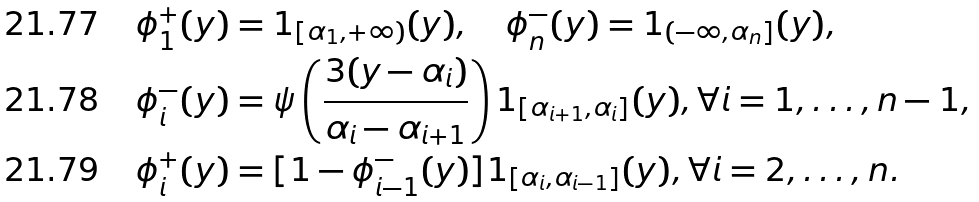<formula> <loc_0><loc_0><loc_500><loc_500>& \phi _ { 1 } ^ { + } ( y ) = 1 _ { [ \alpha _ { 1 } , + \infty ) } ( y ) , \quad \phi _ { n } ^ { - } ( y ) = 1 _ { ( - \infty , \alpha _ { n } ] } ( y ) , \\ & \phi _ { i } ^ { - } ( y ) = \psi \left ( \frac { 3 ( y - \alpha _ { i } ) } { \alpha _ { i } - \alpha _ { i + 1 } } \right ) 1 _ { [ \alpha _ { i + 1 } , \alpha _ { i } ] } ( y ) , \forall i = 1 , \dots , n - 1 , \\ & \phi _ { i } ^ { + } ( y ) = [ 1 - \phi _ { i - 1 } ^ { - } ( y ) ] 1 _ { [ \alpha _ { i } , \alpha _ { i - 1 } ] } ( y ) , \forall i = 2 , \dots , n .</formula> 